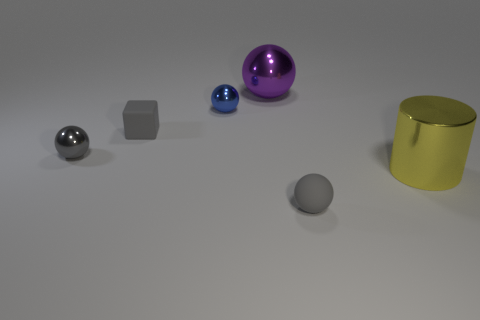Subtract all large balls. How many balls are left? 3 Subtract all brown cubes. How many gray spheres are left? 2 Subtract all blue spheres. How many spheres are left? 3 Add 1 blue metal things. How many objects exist? 7 Subtract all brown spheres. Subtract all purple cylinders. How many spheres are left? 4 Subtract all large cylinders. Subtract all tiny purple spheres. How many objects are left? 5 Add 1 small gray shiny things. How many small gray shiny things are left? 2 Add 6 tiny green blocks. How many tiny green blocks exist? 6 Subtract 0 red cylinders. How many objects are left? 6 Subtract all blocks. How many objects are left? 5 